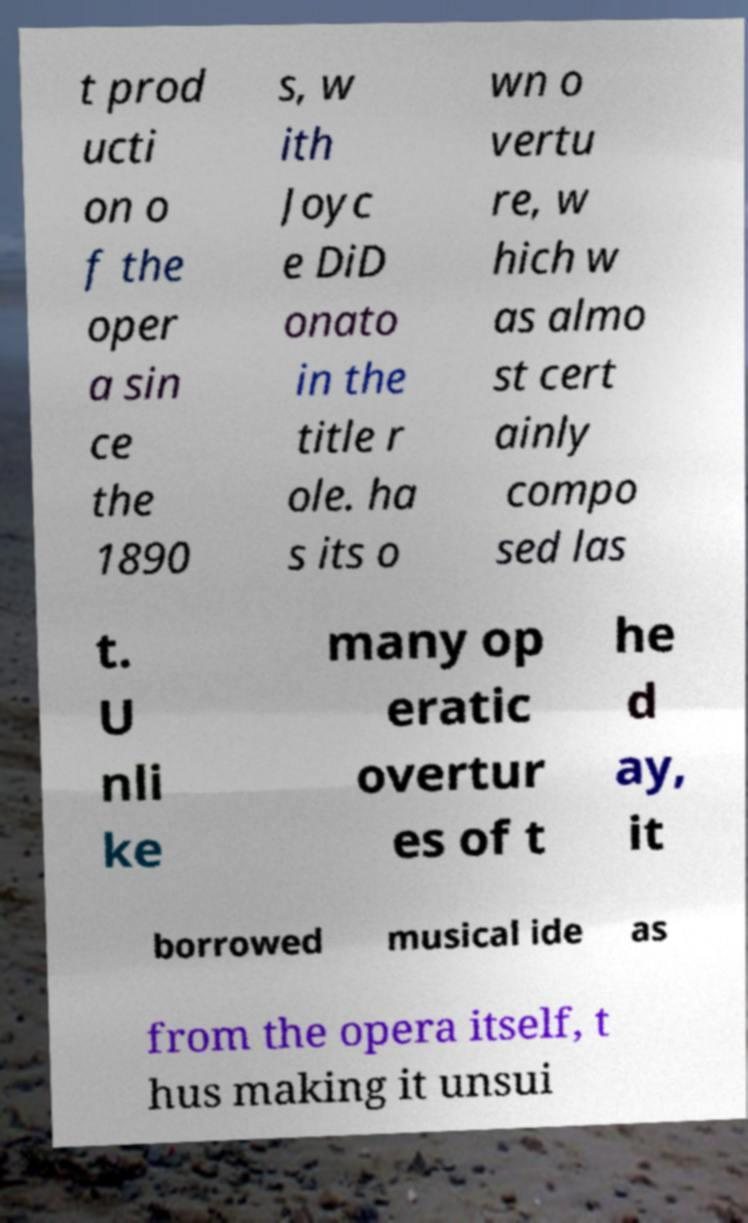Could you assist in decoding the text presented in this image and type it out clearly? t prod ucti on o f the oper a sin ce the 1890 s, w ith Joyc e DiD onato in the title r ole. ha s its o wn o vertu re, w hich w as almo st cert ainly compo sed las t. U nli ke many op eratic overtur es of t he d ay, it borrowed musical ide as from the opera itself, t hus making it unsui 